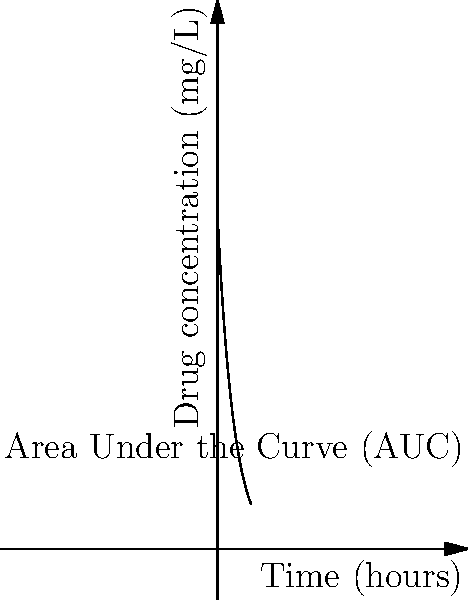As a clinical researcher, you're studying the pharmacokinetics of a new drug. The graph shows the drug concentration in the blood over time. The concentration (in mg/L) can be modeled by the function $C(t) = 100e^{-0.2t}$, where $t$ is time in hours. Calculate the Area Under the Curve (AUC) from $t=0$ to $t=10$ hours. Round your answer to the nearest whole number. To calculate the Area Under the Curve (AUC), we need to integrate the concentration function from $t=0$ to $t=10$. Here's the step-by-step process:

1) The concentration function is $C(t) = 100e^{-0.2t}$

2) We need to calculate $\int_{0}^{10} 100e^{-0.2t} dt$

3) Let's solve this integral:
   
   $AUC = \int_{0}^{10} 100e^{-0.2t} dt$
   
   $= -500e^{-0.2t} \big|_{0}^{10}$
   
   $= -500(e^{-2} - e^{0})$
   
   $= -500(0.1353 - 1)$
   
   $= -500(-0.8647)$
   
   $= 432.35$

4) Rounding to the nearest whole number: 432

This AUC value represents the total drug exposure over the 10-hour period.
Answer: 432 mg·h/L 